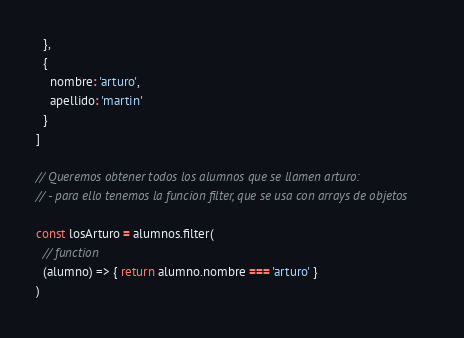<code> <loc_0><loc_0><loc_500><loc_500><_JavaScript_>  },
  {
    nombre: 'arturo',
    apellido: 'martin'
  }
]

// Queremos obtener todos los alumnos que se llamen arturo:
// - para ello tenemos la funcion filter, que se usa con arrays de objetos

const losArturo = alumnos.filter(
  // function
  (alumno) => { return alumno.nombre === 'arturo' }
)
</code> 